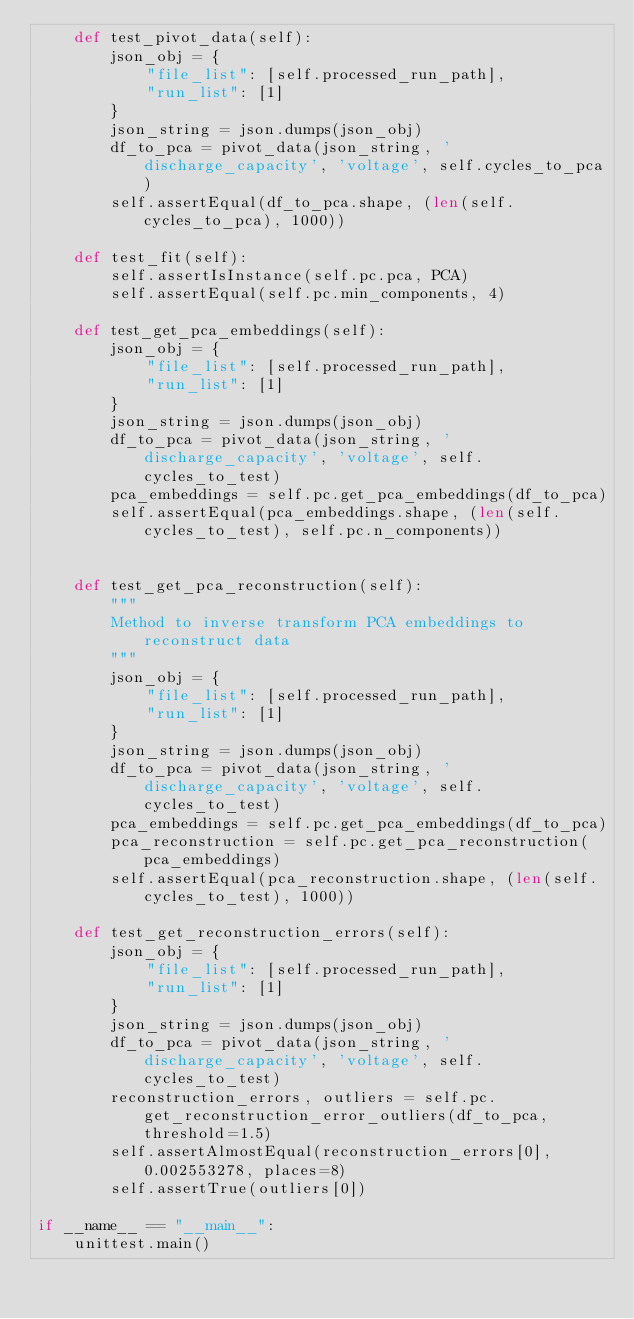Convert code to text. <code><loc_0><loc_0><loc_500><loc_500><_Python_>    def test_pivot_data(self):
        json_obj = {
            "file_list": [self.processed_run_path],
            "run_list": [1]
        }
        json_string = json.dumps(json_obj)
        df_to_pca = pivot_data(json_string, 'discharge_capacity', 'voltage', self.cycles_to_pca)
        self.assertEqual(df_to_pca.shape, (len(self.cycles_to_pca), 1000))

    def test_fit(self):
        self.assertIsInstance(self.pc.pca, PCA)
        self.assertEqual(self.pc.min_components, 4)

    def test_get_pca_embeddings(self):
        json_obj = {
            "file_list": [self.processed_run_path],
            "run_list": [1]
        }
        json_string = json.dumps(json_obj)
        df_to_pca = pivot_data(json_string, 'discharge_capacity', 'voltage', self.cycles_to_test)
        pca_embeddings = self.pc.get_pca_embeddings(df_to_pca)
        self.assertEqual(pca_embeddings.shape, (len(self.cycles_to_test), self.pc.n_components))


    def test_get_pca_reconstruction(self):
        """
        Method to inverse transform PCA embeddings to reconstruct data
        """
        json_obj = {
            "file_list": [self.processed_run_path],
            "run_list": [1]
        }
        json_string = json.dumps(json_obj)
        df_to_pca = pivot_data(json_string, 'discharge_capacity', 'voltage', self.cycles_to_test)
        pca_embeddings = self.pc.get_pca_embeddings(df_to_pca)
        pca_reconstruction = self.pc.get_pca_reconstruction(pca_embeddings)
        self.assertEqual(pca_reconstruction.shape, (len(self.cycles_to_test), 1000))

    def test_get_reconstruction_errors(self):
        json_obj = {
            "file_list": [self.processed_run_path],
            "run_list": [1]
        }
        json_string = json.dumps(json_obj)
        df_to_pca = pivot_data(json_string, 'discharge_capacity', 'voltage', self.cycles_to_test)
        reconstruction_errors, outliers = self.pc.get_reconstruction_error_outliers(df_to_pca, threshold=1.5)
        self.assertAlmostEqual(reconstruction_errors[0], 0.002553278, places=8)
        self.assertTrue(outliers[0])

if __name__ == "__main__":
    unittest.main()
</code> 